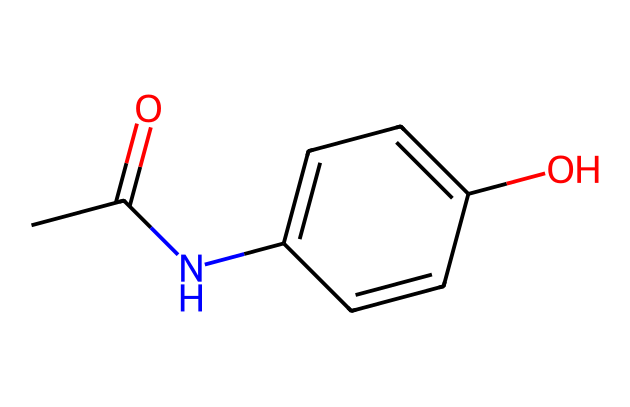How many carbon atoms are present in this molecule? In the provided SMILES, each 'C' represents a carbon atom. Counting these gives a total of 8 carbon atoms in the structure.
Answer: 8 What functional groups are present in acetaminophen? Examining the structure, acetaminophen contains an amide group (–C(=O)N–) and a hydroxyl group (–OH), indicating the presence of functional groups.
Answer: amide and hydroxyl What is the molecular formula of acetaminophen? The molecular formula can be derived from counting the number of each type of atom represented in the SMILES. This yields C8H9NO2.
Answer: C8H9NO2 Describe the main use of acetaminophen. Acetaminophen is primarily used to relieve pain and reduce fever, making it a common analgesic and antipyretic medication.
Answer: pain relief and fever reduction How can the orientation of the hydroxyl group affect the properties of acetaminophen? The orientation of the hydroxyl group can influence the molecule's hydrogen bonding capabilities and solubility in water. Proper orientation allows for efficient interactions with water molecules, thus affecting solubility.
Answer: solubility What type of solid is acetaminophen at room temperature? Acetaminophen exists as a crystalline solid at room temperature, due to its ordered molecular structure.
Answer: crystalline Does acetaminophen have any acidic protons? The presence of a hydroxyl group indicates that acetaminophen does possess an acidic proton that can be released, making it weakly acidic.
Answer: yes 